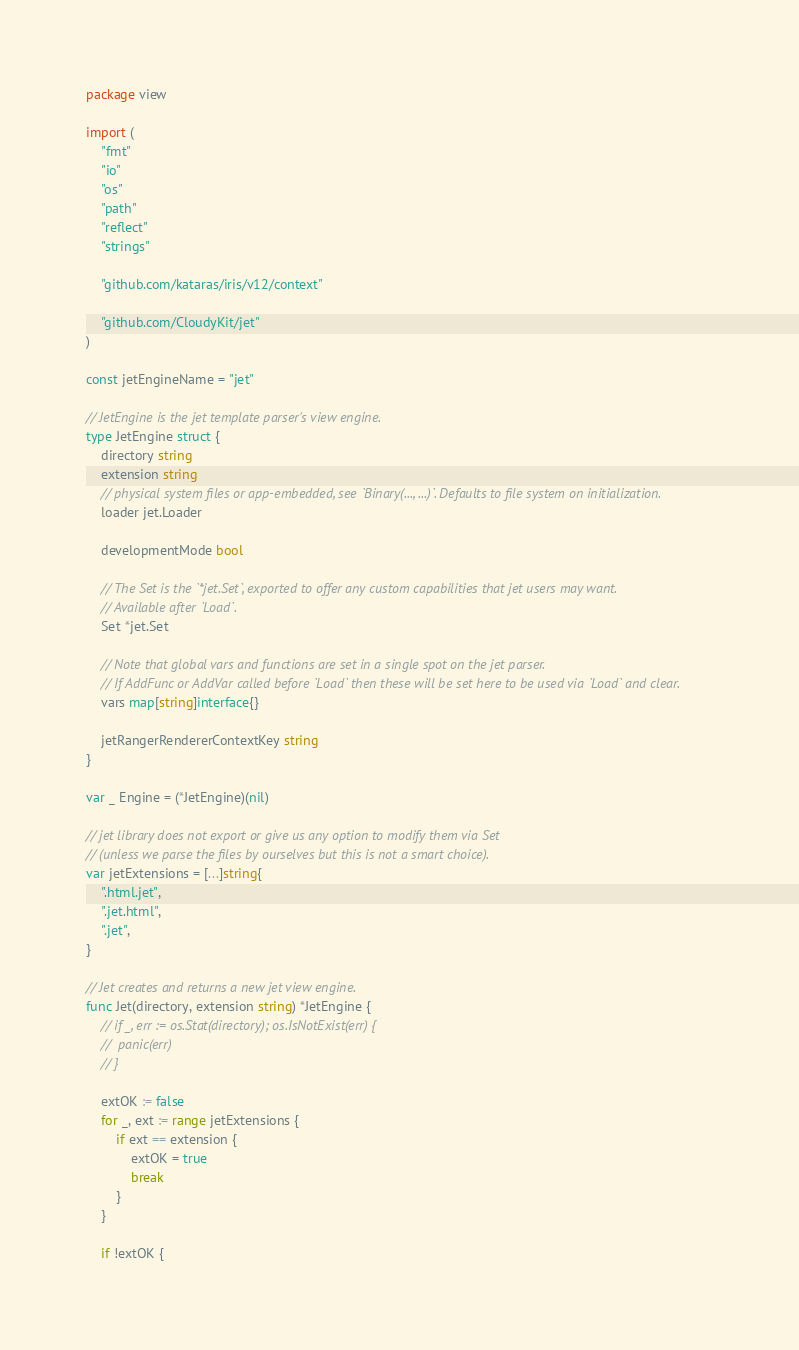Convert code to text. <code><loc_0><loc_0><loc_500><loc_500><_Go_>package view

import (
	"fmt"
	"io"
	"os"
	"path"
	"reflect"
	"strings"

	"github.com/kataras/iris/v12/context"

	"github.com/CloudyKit/jet"
)

const jetEngineName = "jet"

// JetEngine is the jet template parser's view engine.
type JetEngine struct {
	directory string
	extension string
	// physical system files or app-embedded, see `Binary(..., ...)`. Defaults to file system on initialization.
	loader jet.Loader

	developmentMode bool

	// The Set is the `*jet.Set`, exported to offer any custom capabilities that jet users may want.
	// Available after `Load`.
	Set *jet.Set

	// Note that global vars and functions are set in a single spot on the jet parser.
	// If AddFunc or AddVar called before `Load` then these will be set here to be used via `Load` and clear.
	vars map[string]interface{}

	jetRangerRendererContextKey string
}

var _ Engine = (*JetEngine)(nil)

// jet library does not export or give us any option to modify them via Set
// (unless we parse the files by ourselves but this is not a smart choice).
var jetExtensions = [...]string{
	".html.jet",
	".jet.html",
	".jet",
}

// Jet creates and returns a new jet view engine.
func Jet(directory, extension string) *JetEngine {
	// if _, err := os.Stat(directory); os.IsNotExist(err) {
	// 	panic(err)
	// }

	extOK := false
	for _, ext := range jetExtensions {
		if ext == extension {
			extOK = true
			break
		}
	}

	if !extOK {</code> 